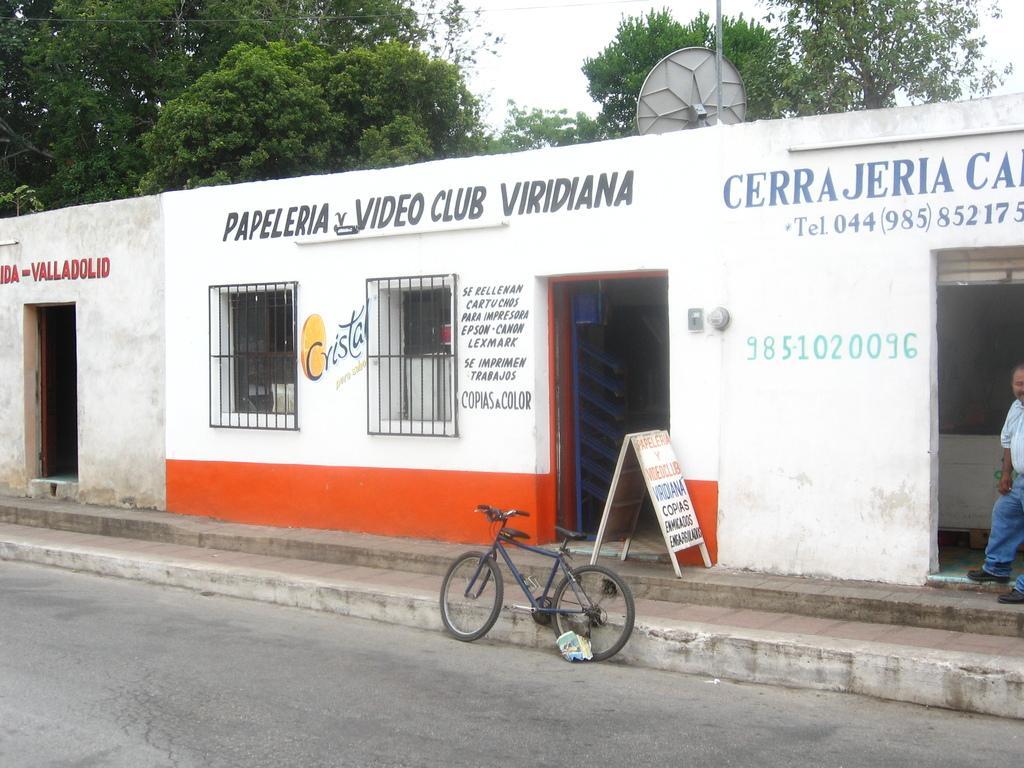In one or two sentences, can you explain what this image depicts? In the center of the image we can see doors and windows to the building. At the bottom of the image we can see cycle on the road. In the background we can see trees and sky. 